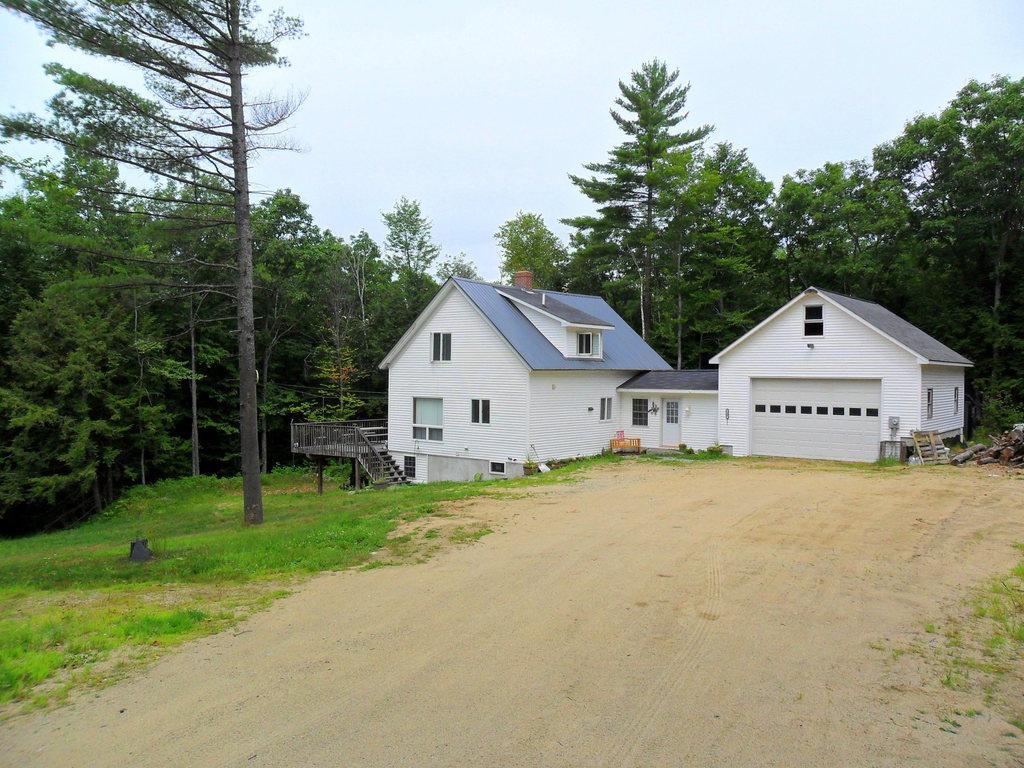How would you summarize this image in a sentence or two? In the foreground of this image, there is the path and the grass. In the background, there is a house, stairs, trees and the sky. 